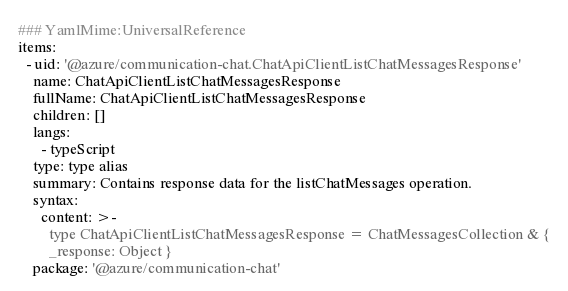<code> <loc_0><loc_0><loc_500><loc_500><_YAML_>### YamlMime:UniversalReference
items:
  - uid: '@azure/communication-chat.ChatApiClientListChatMessagesResponse'
    name: ChatApiClientListChatMessagesResponse
    fullName: ChatApiClientListChatMessagesResponse
    children: []
    langs:
      - typeScript
    type: type alias
    summary: Contains response data for the listChatMessages operation.
    syntax:
      content: >-
        type ChatApiClientListChatMessagesResponse = ChatMessagesCollection & {
        _response: Object }
    package: '@azure/communication-chat'
</code> 